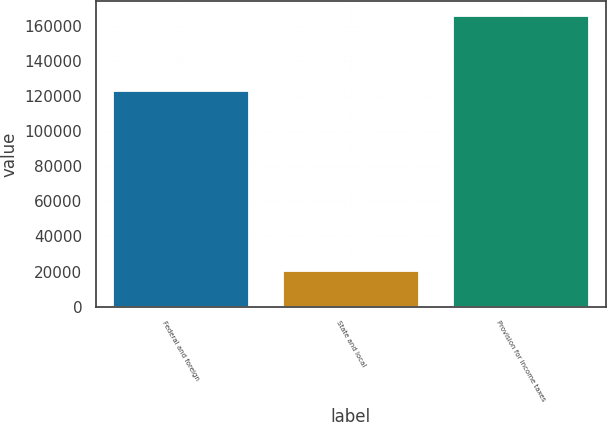<chart> <loc_0><loc_0><loc_500><loc_500><bar_chart><fcel>Federal and foreign<fcel>State and local<fcel>Provision for income taxes<nl><fcel>122872<fcel>20523<fcel>165739<nl></chart> 